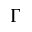Convert formula to latex. <formula><loc_0><loc_0><loc_500><loc_500>\Gamma</formula> 